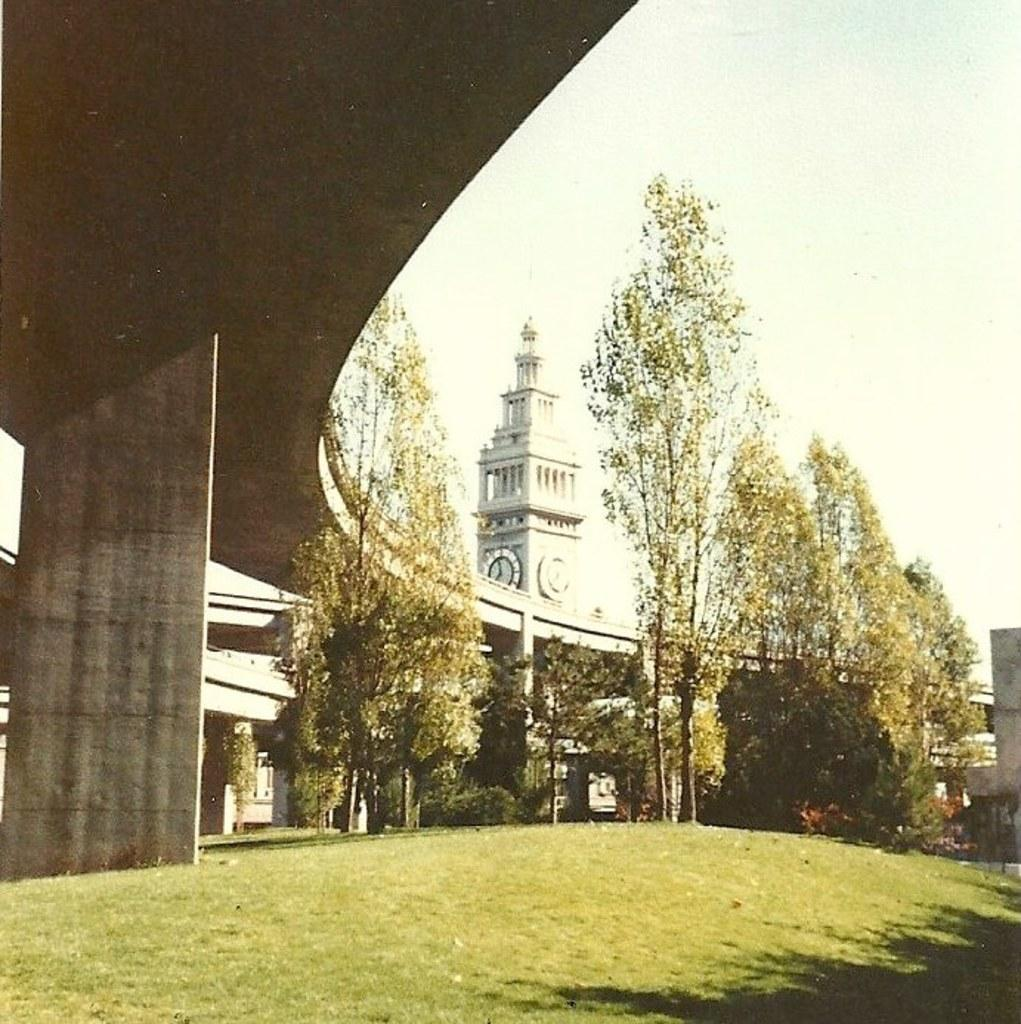What type of surface is visible in the image? There is a greenery ground in the image. What structure is above the ground in the image? There is a bridge above the ground in the image. What can be seen in the background of the image? There are trees and a clock tower in the background of the image. Where is the library located in the image? There is no library present in the image. What type of building can be seen in the image? The image does not show any buildings; it features a bridge above a greenery ground with trees and a clock tower in the background. 